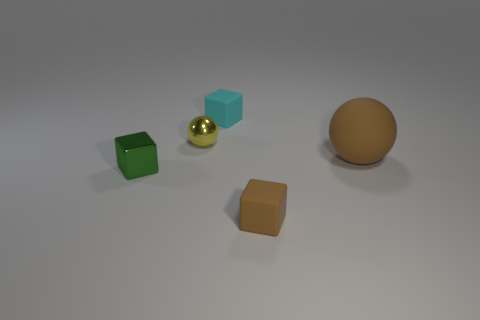What is the shape of the cyan thing that is the same size as the green thing?
Offer a terse response. Cube. What number of tiny things are cyan cubes or green shiny cubes?
Your answer should be compact. 2. Are there any brown matte balls that are on the right side of the ball that is on the left side of the tiny matte thing that is in front of the yellow metal object?
Your answer should be very brief. Yes. Is there another thing that has the same size as the yellow object?
Ensure brevity in your answer.  Yes. What is the material of the yellow object that is the same size as the brown cube?
Your answer should be compact. Metal. There is a green object; does it have the same size as the metallic object that is behind the tiny green shiny block?
Give a very brief answer. Yes. How many rubber things are small red cylinders or things?
Offer a very short reply. 3. How many big brown things are the same shape as the cyan rubber thing?
Your response must be concise. 0. There is a small block that is the same color as the large sphere; what is it made of?
Your answer should be compact. Rubber. Does the matte object that is left of the brown block have the same size as the matte cube in front of the small cyan rubber thing?
Keep it short and to the point. Yes. 